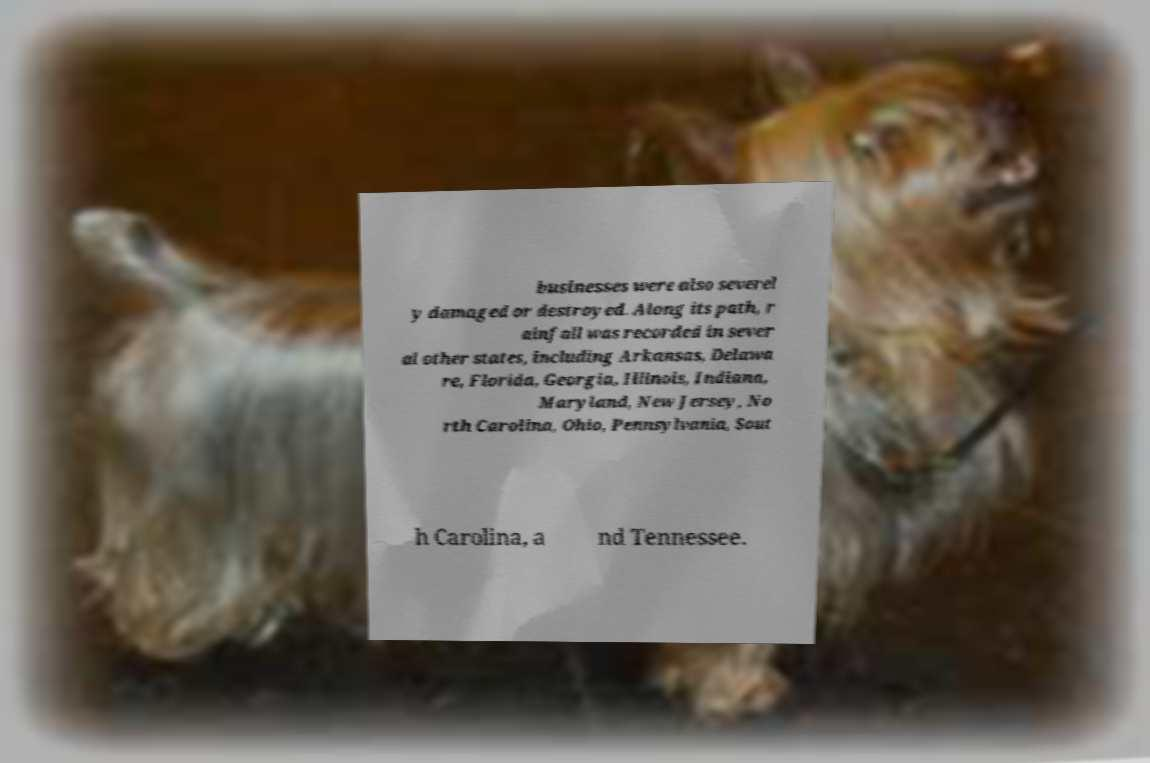Can you accurately transcribe the text from the provided image for me? businesses were also severel y damaged or destroyed. Along its path, r ainfall was recorded in sever al other states, including Arkansas, Delawa re, Florida, Georgia, Illinois, Indiana, Maryland, New Jersey, No rth Carolina, Ohio, Pennsylvania, Sout h Carolina, a nd Tennessee. 